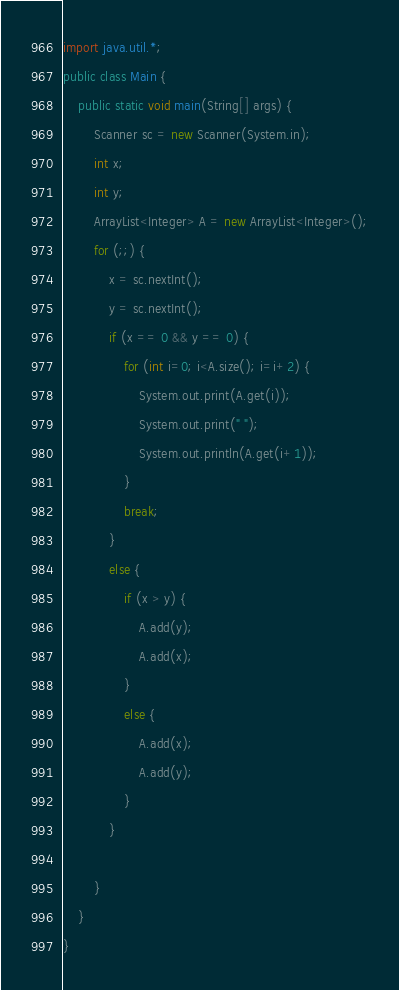Convert code to text. <code><loc_0><loc_0><loc_500><loc_500><_Java_>import java.util.*;
public class Main {
    public static void main(String[] args) {
        Scanner sc = new Scanner(System.in);
        int x;
        int y;
        ArrayList<Integer> A = new ArrayList<Integer>();
        for (;;) {
            x = sc.nextInt();
            y = sc.nextInt();
            if (x == 0 && y == 0) {
                for (int i=0; i<A.size(); i=i+2) {
                    System.out.print(A.get(i));
                    System.out.print(" ");
                    System.out.println(A.get(i+1));
                }
                break;
            }
            else {
                if (x > y) {
                    A.add(y);
                    A.add(x);
                }
                else {
                    A.add(x);
                    A.add(y);
                }
            }

        }
    }
}
</code> 